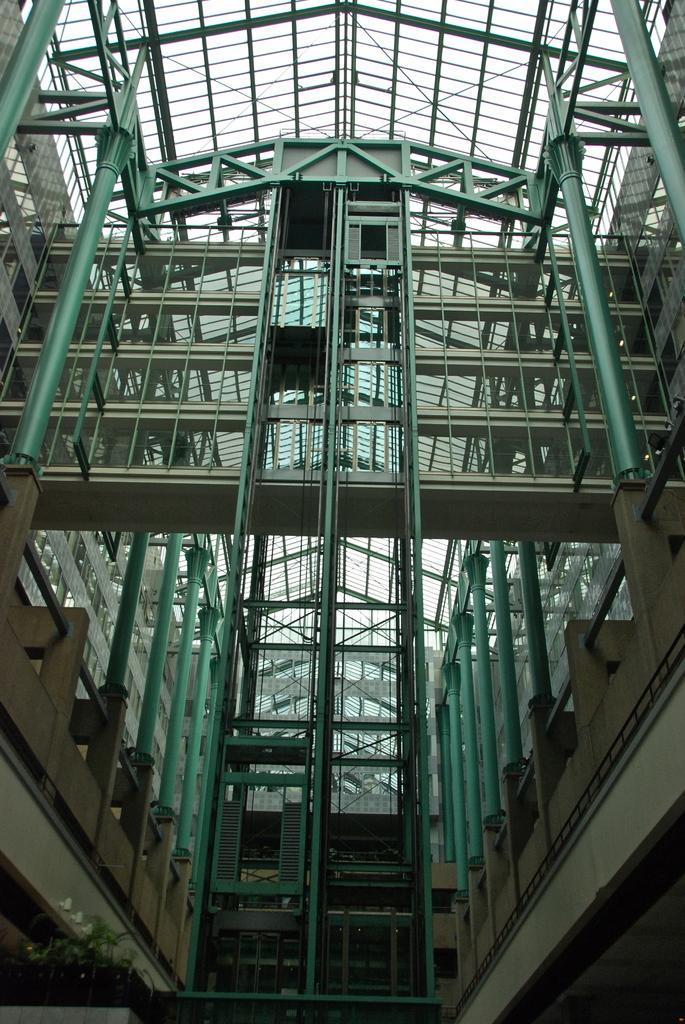How would you summarize this image in a sentence or two? A picture inside of a building. These are pillars. Here we can see rooftop and plants. 